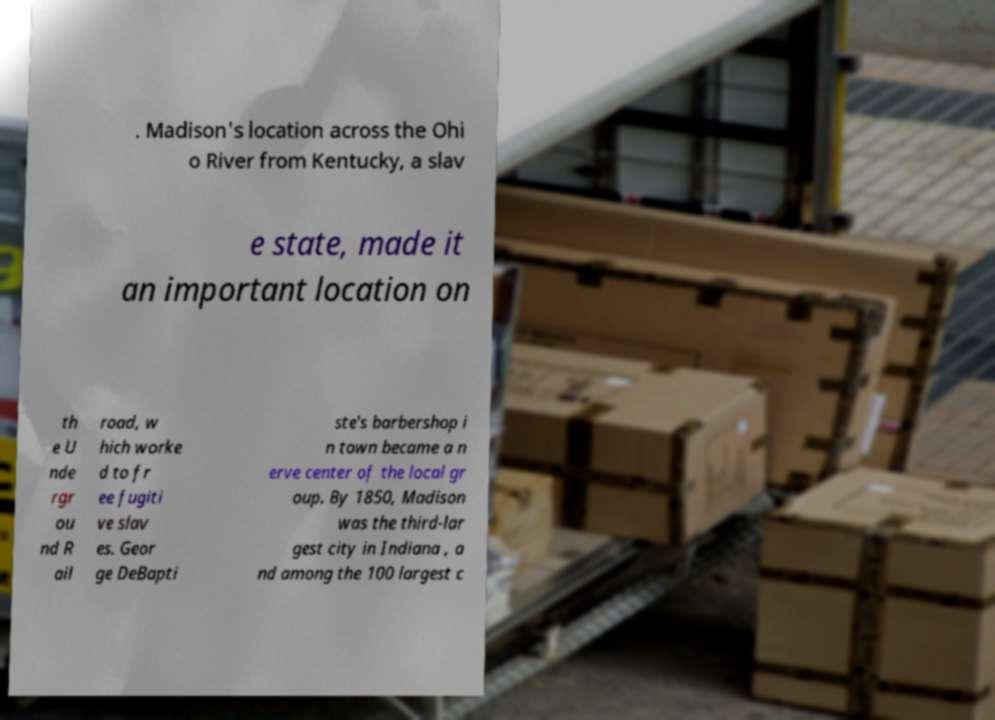Please read and relay the text visible in this image. What does it say? . Madison's location across the Ohi o River from Kentucky, a slav e state, made it an important location on th e U nde rgr ou nd R ail road, w hich worke d to fr ee fugiti ve slav es. Geor ge DeBapti ste's barbershop i n town became a n erve center of the local gr oup. By 1850, Madison was the third-lar gest city in Indiana , a nd among the 100 largest c 